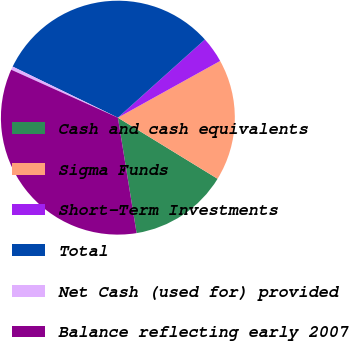Convert chart to OTSL. <chart><loc_0><loc_0><loc_500><loc_500><pie_chart><fcel>Cash and cash equivalents<fcel>Sigma Funds<fcel>Short-Term Investments<fcel>Total<fcel>Net Cash (used for) provided<fcel>Balance reflecting early 2007<nl><fcel>13.69%<fcel>16.81%<fcel>3.59%<fcel>31.16%<fcel>0.47%<fcel>34.28%<nl></chart> 